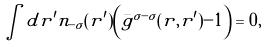<formula> <loc_0><loc_0><loc_500><loc_500>\int d { r ^ { \prime } } n _ { - \sigma } ( { r ^ { \prime } } ) \left ( { \bar { g } } ^ { \sigma - \sigma } ( { r , r ^ { \prime } } ) - 1 \right ) = 0 ,</formula> 